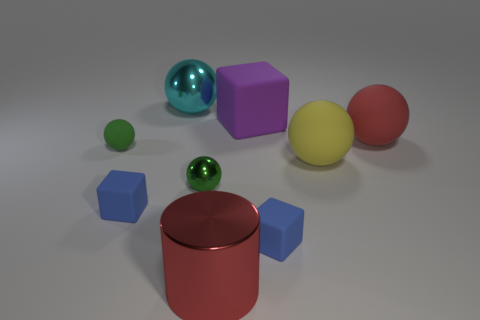What is the color of the block left of the cyan sphere?
Give a very brief answer. Blue. What is the material of the small thing that is both in front of the green metal sphere and on the left side of the big purple matte object?
Make the answer very short. Rubber. There is a blue matte thing right of the large cyan thing; what number of small cubes are behind it?
Make the answer very short. 1. What shape is the yellow object?
Your response must be concise. Sphere. What shape is the yellow thing that is made of the same material as the purple thing?
Offer a very short reply. Sphere. Does the large red thing that is behind the green rubber ball have the same shape as the purple thing?
Make the answer very short. No. There is a large metal thing on the left side of the big metallic cylinder; what shape is it?
Provide a succinct answer. Sphere. There is a large thing that is the same color as the big cylinder; what is its shape?
Make the answer very short. Sphere. What number of brown cubes have the same size as the purple cube?
Provide a short and direct response. 0. What is the color of the cylinder?
Make the answer very short. Red. 